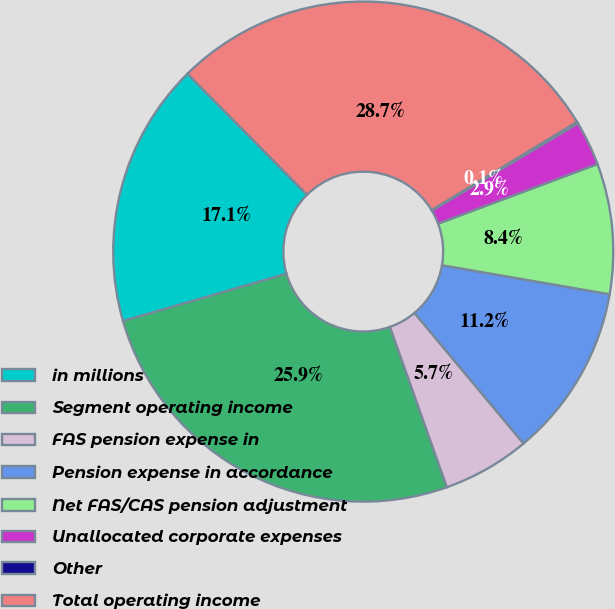Convert chart. <chart><loc_0><loc_0><loc_500><loc_500><pie_chart><fcel>in millions<fcel>Segment operating income<fcel>FAS pension expense in<fcel>Pension expense in accordance<fcel>Net FAS/CAS pension adjustment<fcel>Unallocated corporate expenses<fcel>Other<fcel>Total operating income<nl><fcel>17.08%<fcel>25.94%<fcel>5.65%<fcel>11.19%<fcel>8.42%<fcel>2.88%<fcel>0.11%<fcel>28.72%<nl></chart> 